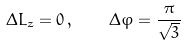Convert formula to latex. <formula><loc_0><loc_0><loc_500><loc_500>\Delta L _ { z } = 0 \, , \quad \Delta \varphi = \frac { \pi } { \sqrt { 3 } }</formula> 